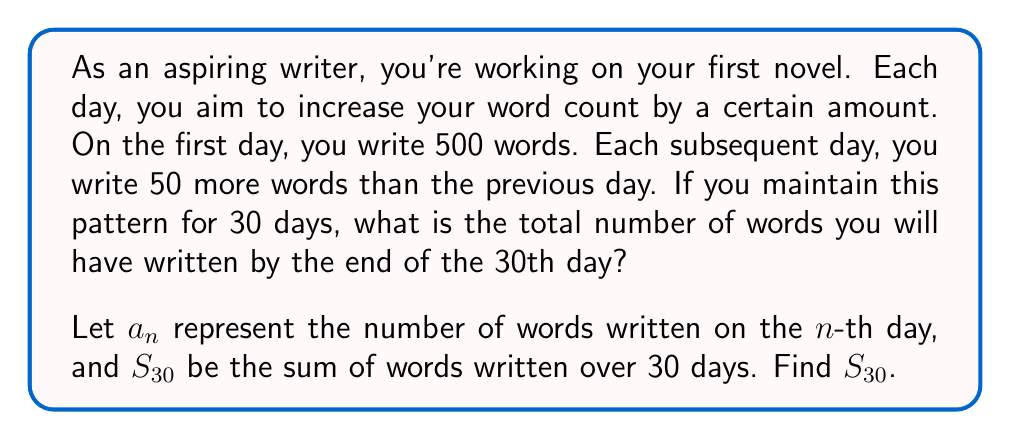Can you answer this question? Let's approach this step-by-step:

1) First, we need to identify the sequence. Given the information:
   $a_1 = 500$ (first day)
   $a_2 = 500 + 50 = 550$ (second day)
   $a_3 = 550 + 50 = 600$ (third day)
   
   We can see that this is an arithmetic sequence with:
   $a_1 = 500$ (first term)
   $d = 50$ (common difference)

2) The general term of an arithmetic sequence is given by:
   $a_n = a_1 + (n-1)d$
   
   In this case: $a_n = 500 + (n-1)50 = 500 + 50n - 50 = 50n + 450$

3) To find the sum of the first 30 terms, we can use the formula for the partial sum of an arithmetic sequence:
   $$S_n = \frac{n}{2}(a_1 + a_n)$$

4) We need to find $a_{30}$:
   $a_{30} = 50(30) + 450 = 1950$

5) Now we can calculate $S_{30}$:
   $$S_{30} = \frac{30}{2}(500 + 1950) = 15(2450) = 36,750$$

Therefore, the total number of words written over 30 days is 36,750.
Answer: $S_{30} = 36,750$ words 